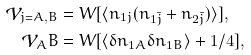<formula> <loc_0><loc_0><loc_500><loc_500>\mathcal { V } _ { j = A , B } & = W [ \langle n _ { 1 j } ( n _ { 1 \bar { j } } + n _ { 2 \bar { j } } ) \rangle ] , \\ \mathcal { V } _ { A } B & = W [ \langle \delta n _ { 1 A } \delta n _ { 1 B } \rangle + 1 / 4 ] ,</formula> 